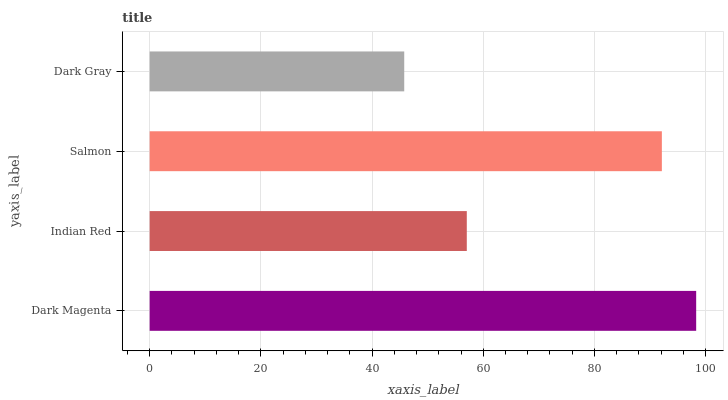Is Dark Gray the minimum?
Answer yes or no. Yes. Is Dark Magenta the maximum?
Answer yes or no. Yes. Is Indian Red the minimum?
Answer yes or no. No. Is Indian Red the maximum?
Answer yes or no. No. Is Dark Magenta greater than Indian Red?
Answer yes or no. Yes. Is Indian Red less than Dark Magenta?
Answer yes or no. Yes. Is Indian Red greater than Dark Magenta?
Answer yes or no. No. Is Dark Magenta less than Indian Red?
Answer yes or no. No. Is Salmon the high median?
Answer yes or no. Yes. Is Indian Red the low median?
Answer yes or no. Yes. Is Dark Magenta the high median?
Answer yes or no. No. Is Dark Magenta the low median?
Answer yes or no. No. 